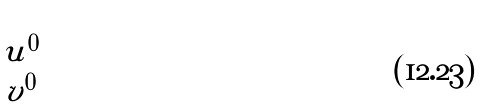Convert formula to latex. <formula><loc_0><loc_0><loc_500><loc_500>\begin{pmatrix} u ^ { 0 } \\ v ^ { 0 } \end{pmatrix}</formula> 